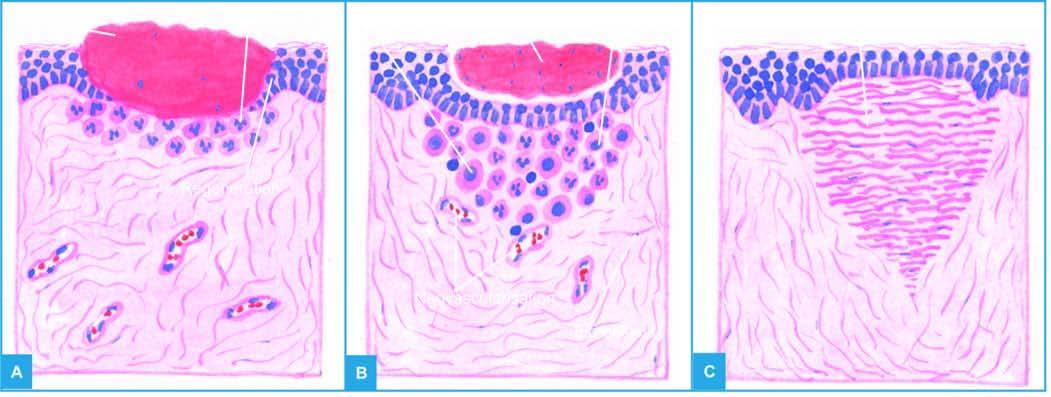what spurs from the margins of wound?
Answer the question using a single word or phrase. Epithelial 